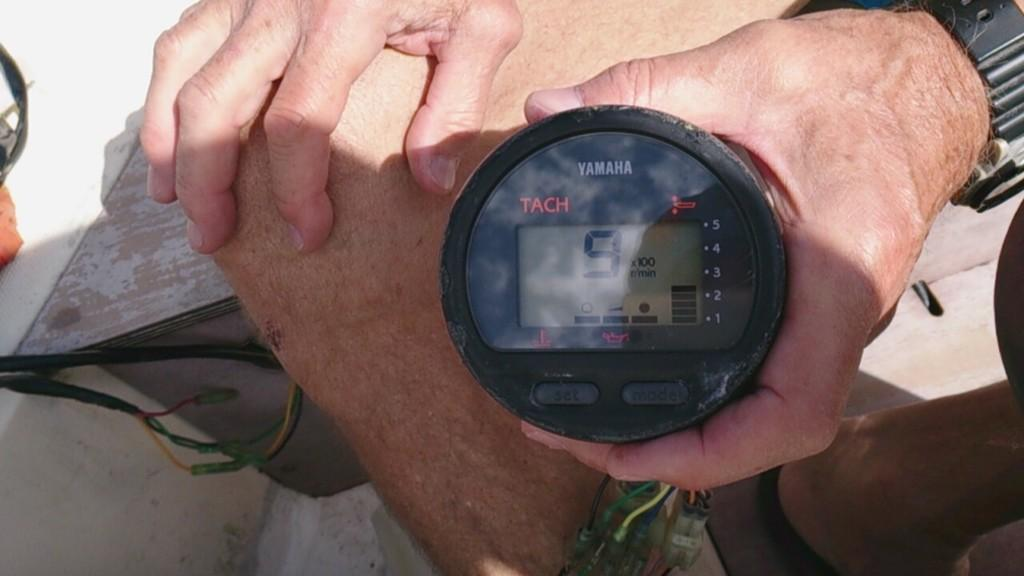Provide a one-sentence caption for the provided image. A tachometer made by Yamaha with the number 9 on the display. 